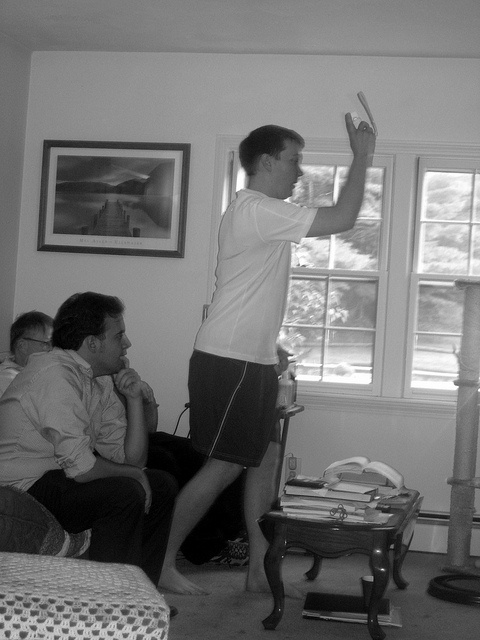Describe the objects in this image and their specific colors. I can see people in gray, black, darkgray, and lightgray tones, people in gray and black tones, couch in gray, darkgray, lightgray, and black tones, couch in black and gray tones, and couch in black and gray tones in this image. 